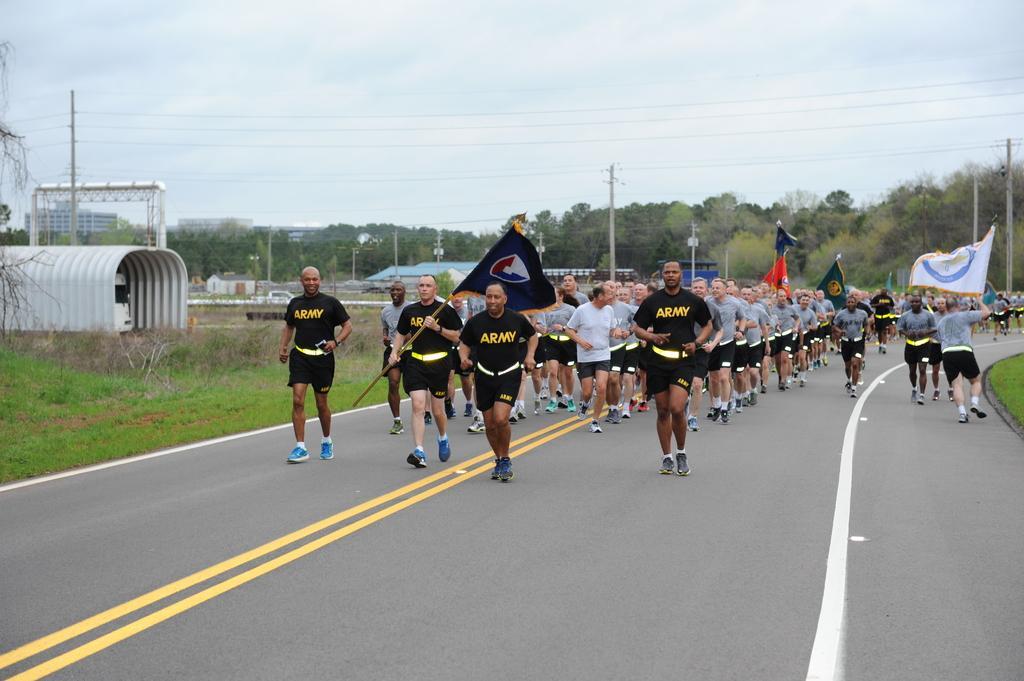Please provide a concise description of this image. In this image we can see people jogging on the road. There are flags. In the background of the image there are trees, electric poles. At the image there is sky. To the left side of the image there is grass. 